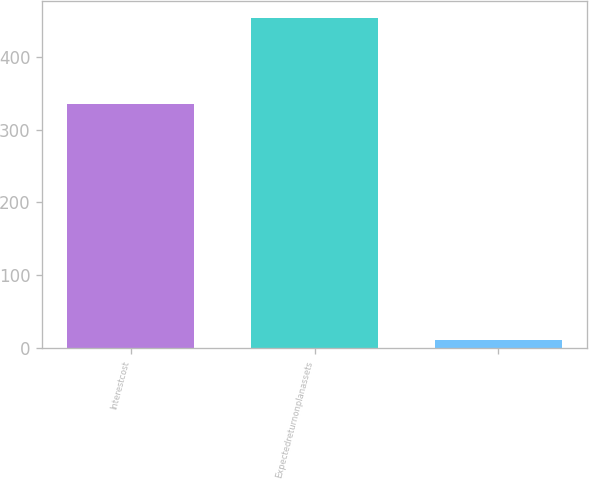<chart> <loc_0><loc_0><loc_500><loc_500><bar_chart><fcel>Interestcost<fcel>Expectedreturnonplanassets<fcel>Unnamed: 2<nl><fcel>335<fcel>454<fcel>11<nl></chart> 